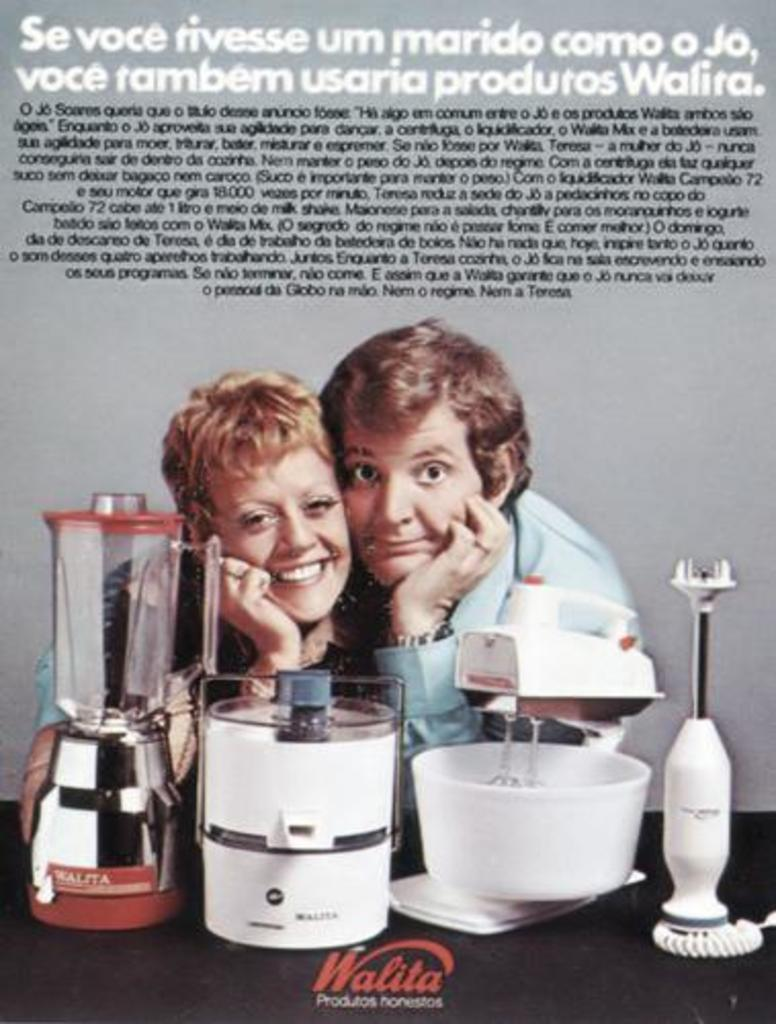<image>
Give a short and clear explanation of the subsequent image. Walita logo in red for a blender, cake mixer, and food mixer. 